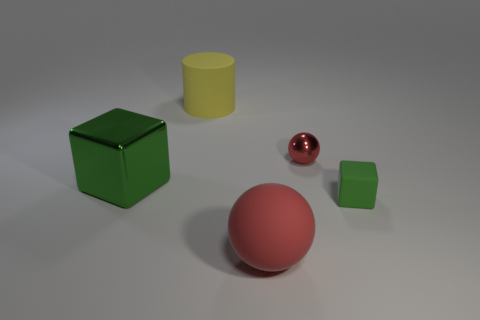Add 2 big cylinders. How many objects exist? 7 Subtract all balls. How many objects are left? 3 Add 3 tiny green matte things. How many tiny green matte things are left? 4 Add 3 small things. How many small things exist? 5 Subtract 0 gray cylinders. How many objects are left? 5 Subtract all small cyan metallic cylinders. Subtract all tiny green matte objects. How many objects are left? 4 